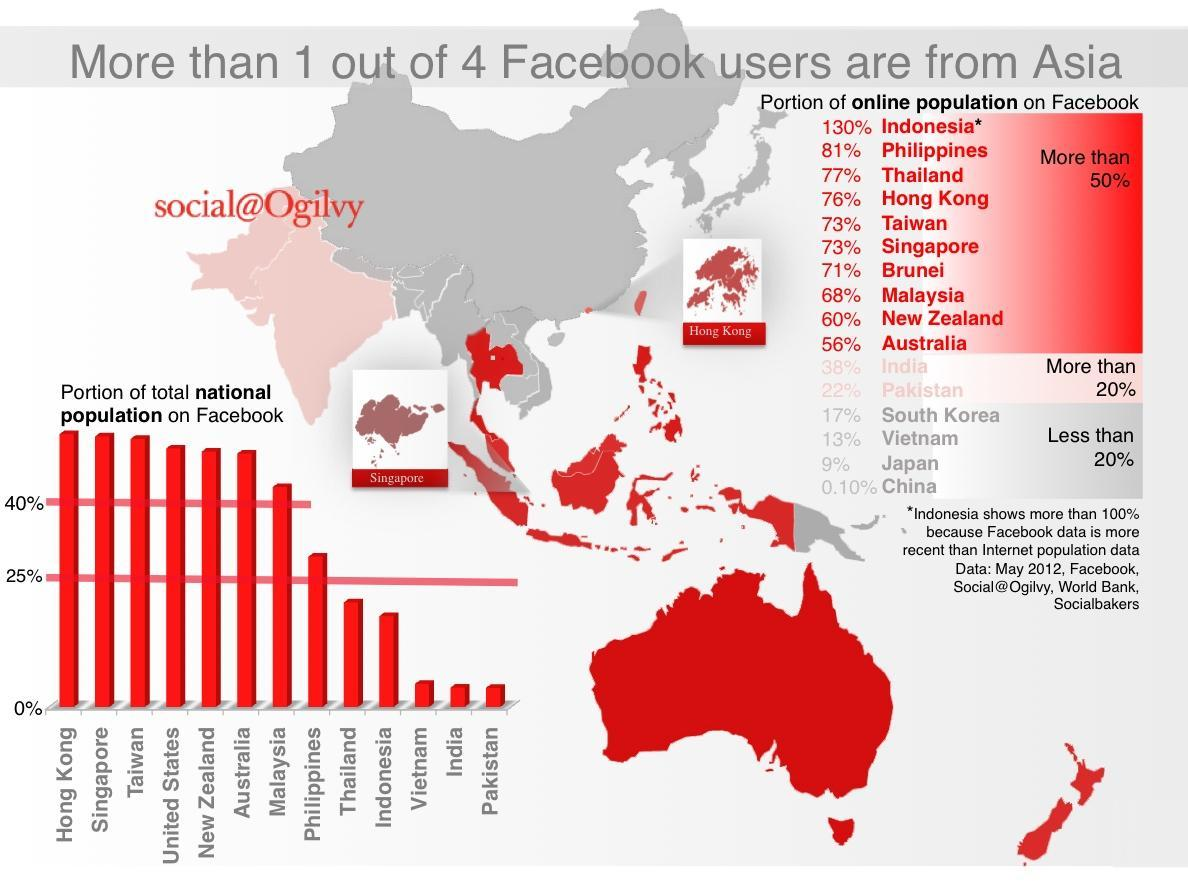How many countries have more than 40% portion of the total national population on Facebook?
Answer the question with a short phrase. 7 How many countries have less than 20% portion of the online population on Facebook? 4 How many countries have more than 20% portion of the online population on Facebook? 2 How many countries have more than 50% portion of the online population on Facebook? 10 How many countries have a 0-25% portion of the total national population on Facebook? 5 